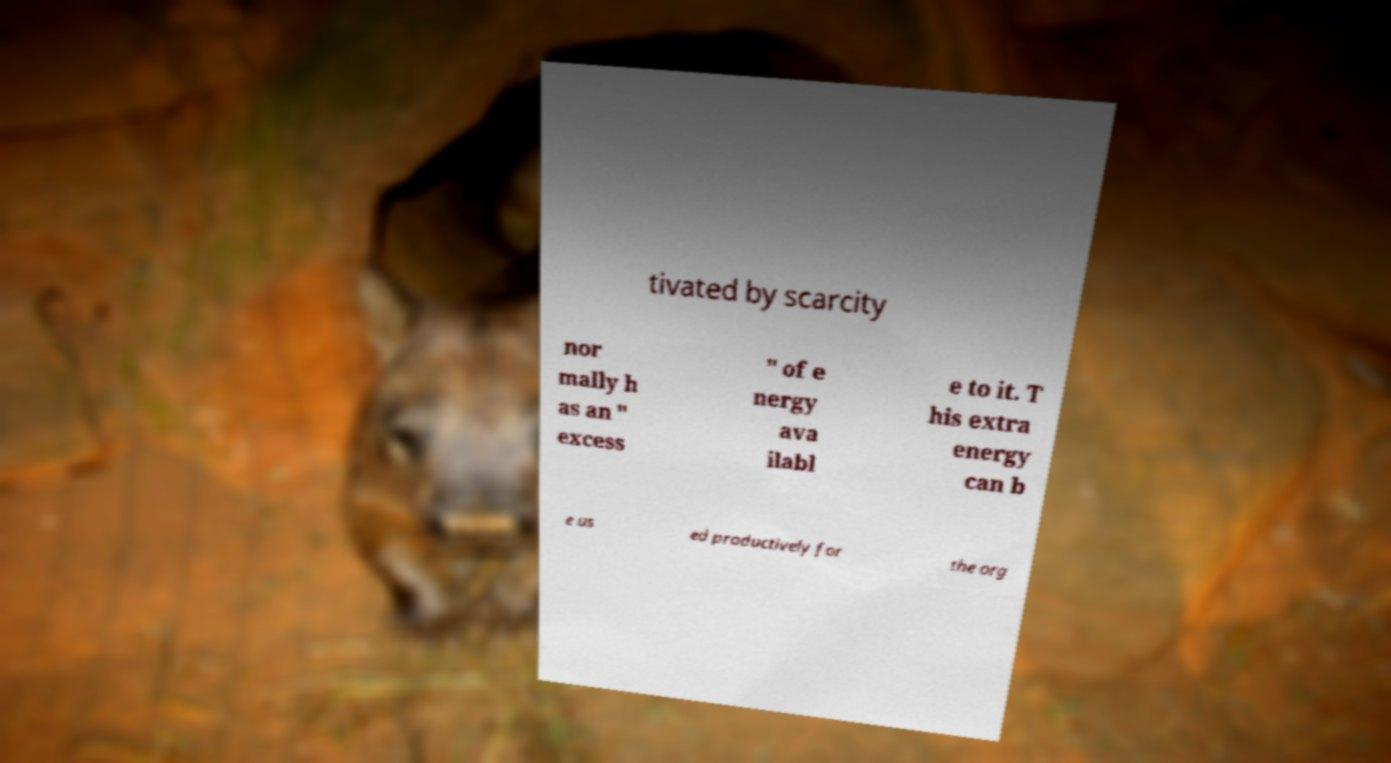Could you extract and type out the text from this image? tivated by scarcity nor mally h as an " excess " of e nergy ava ilabl e to it. T his extra energy can b e us ed productively for the org 